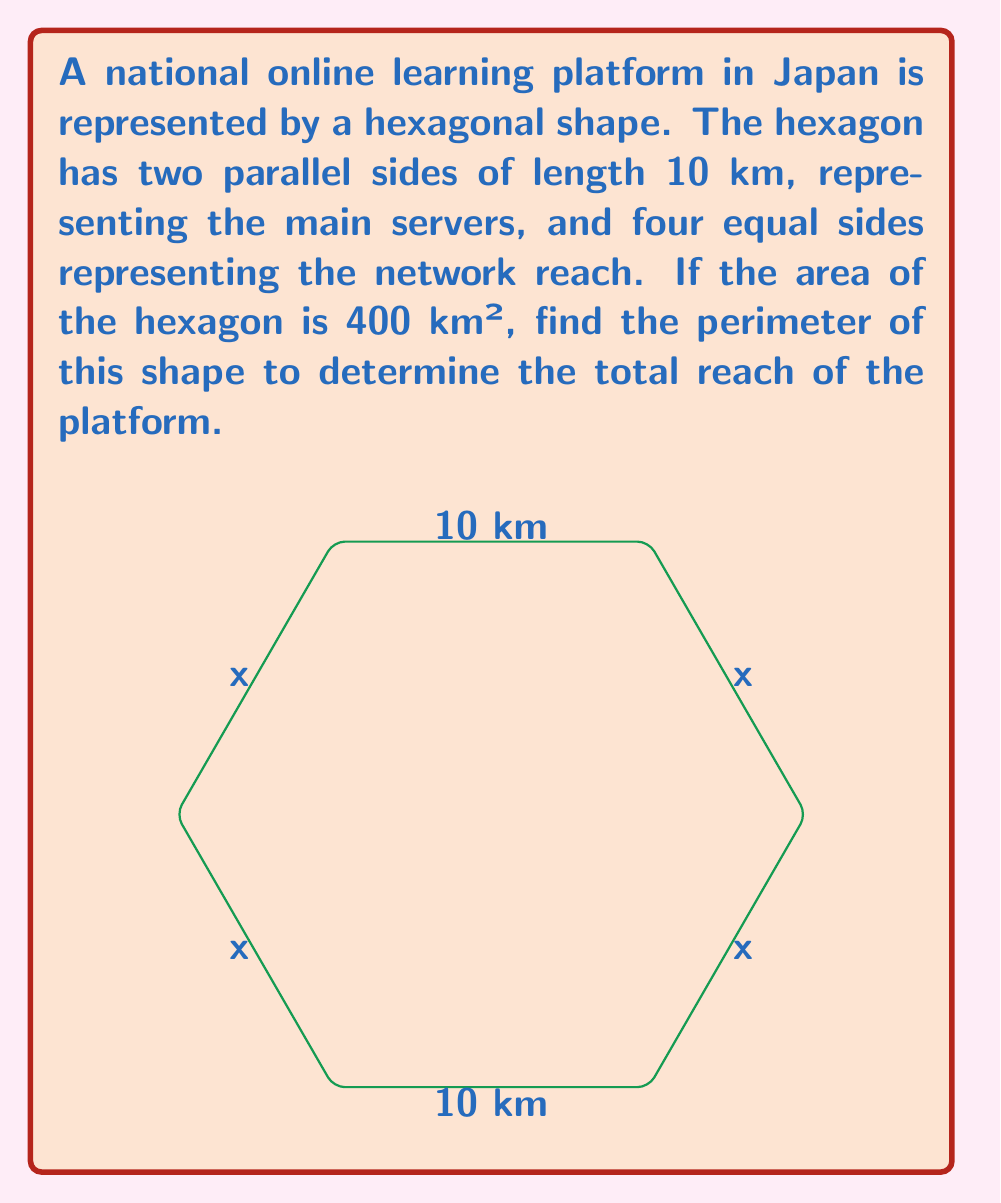Show me your answer to this math problem. Let's approach this step-by-step:

1) Let the length of each of the four equal sides be $x$ km.

2) The area of a regular hexagon is given by:
   $$A = \frac{3\sqrt{3}}{2}a^2$$
   where $a$ is the length of a side.

3) However, our hexagon is not regular. We can split it into a rectangle and two equilateral triangles:
   $$A = 10x + 2 \cdot \frac{\sqrt{3}}{4}x^2$$

4) We're given that the area is 400 km². So we can set up the equation:
   $$400 = 10x + \frac{\sqrt{3}}{2}x^2$$

5) Simplify by multiplying both sides by 2:
   $$800 = 20x + \sqrt{3}x^2$$

6) Rearrange to standard form:
   $$\sqrt{3}x^2 + 20x - 800 = 0$$

7) This is a quadratic equation. We can solve it using the quadratic formula:
   $$x = \frac{-b \pm \sqrt{b^2 - 4ac}}{2a}$$
   where $a = \sqrt{3}$, $b = 20$, and $c = -800$

8) Plugging in these values:
   $$x = \frac{-20 \pm \sqrt{400 + 4\sqrt{3} \cdot 800}}{2\sqrt{3}}$$

9) Simplifying:
   $$x = \frac{-20 \pm \sqrt{3600}}{2\sqrt{3}} = \frac{-20 \pm 60}{2\sqrt{3}}$$

10) We take the positive solution:
    $$x = \frac{40}{2\sqrt{3}} = \frac{20}{\sqrt{3}} \approx 11.55 \text{ km}$$

11) The perimeter is the sum of all sides:
    $$P = 10 + 10 + 4x = 20 + 4 \cdot \frac{20}{\sqrt{3}}$$

12) Simplifying:
    $$P = 20 + \frac{80}{\sqrt{3}} \approx 66.19 \text{ km}$$
Answer: $20 + \frac{80}{\sqrt{3}}$ km 